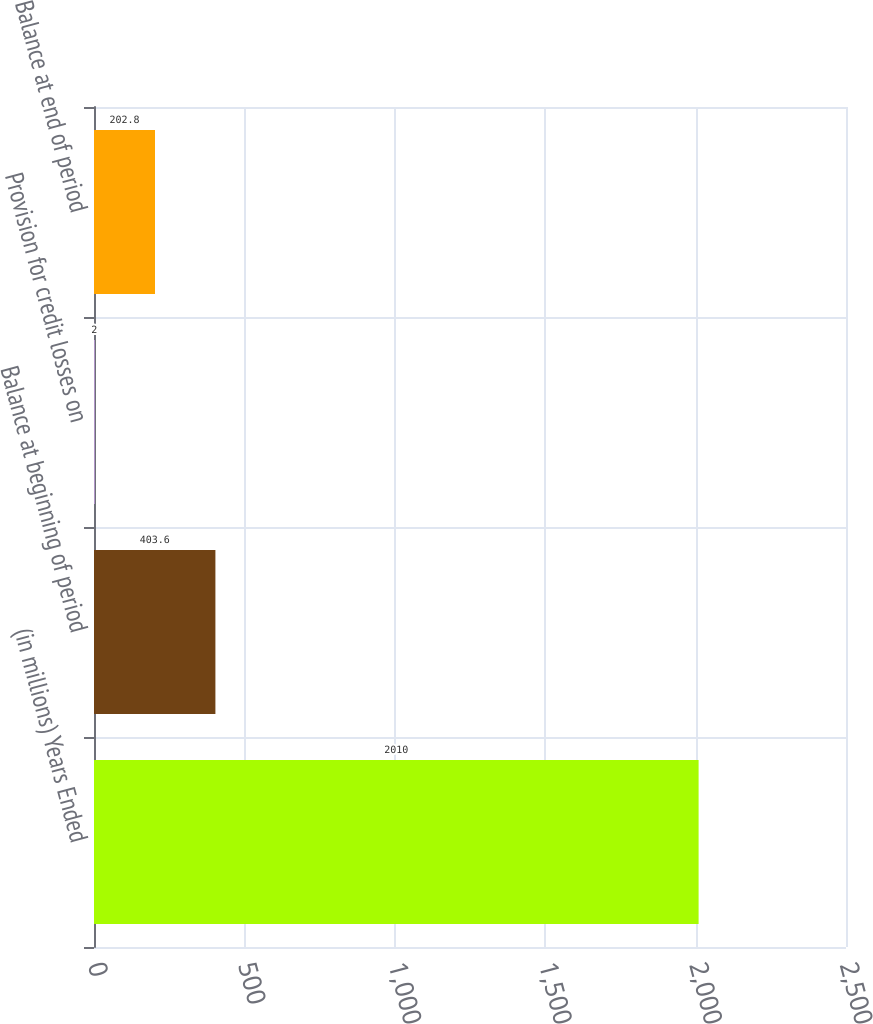<chart> <loc_0><loc_0><loc_500><loc_500><bar_chart><fcel>(in millions) Years Ended<fcel>Balance at beginning of period<fcel>Provision for credit losses on<fcel>Balance at end of period<nl><fcel>2010<fcel>403.6<fcel>2<fcel>202.8<nl></chart> 